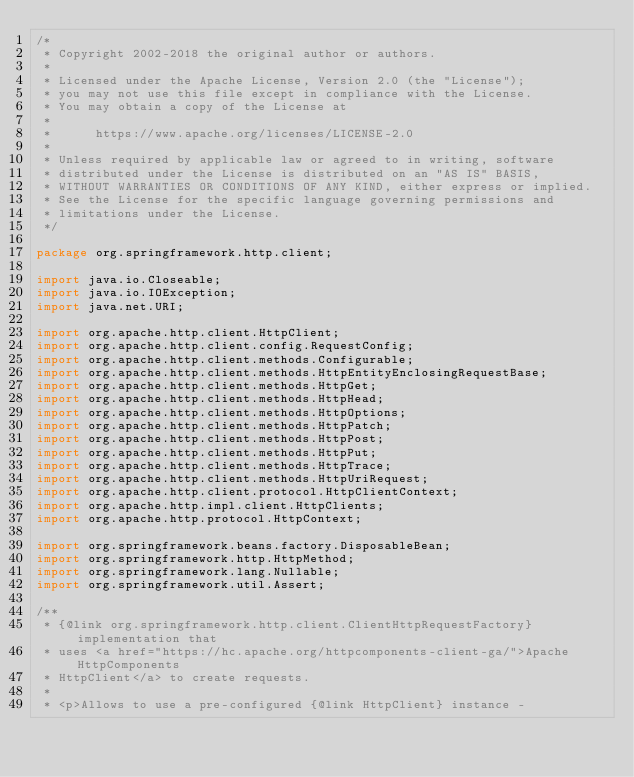Convert code to text. <code><loc_0><loc_0><loc_500><loc_500><_Java_>/*
 * Copyright 2002-2018 the original author or authors.
 *
 * Licensed under the Apache License, Version 2.0 (the "License");
 * you may not use this file except in compliance with the License.
 * You may obtain a copy of the License at
 *
 *      https://www.apache.org/licenses/LICENSE-2.0
 *
 * Unless required by applicable law or agreed to in writing, software
 * distributed under the License is distributed on an "AS IS" BASIS,
 * WITHOUT WARRANTIES OR CONDITIONS OF ANY KIND, either express or implied.
 * See the License for the specific language governing permissions and
 * limitations under the License.
 */

package org.springframework.http.client;

import java.io.Closeable;
import java.io.IOException;
import java.net.URI;

import org.apache.http.client.HttpClient;
import org.apache.http.client.config.RequestConfig;
import org.apache.http.client.methods.Configurable;
import org.apache.http.client.methods.HttpEntityEnclosingRequestBase;
import org.apache.http.client.methods.HttpGet;
import org.apache.http.client.methods.HttpHead;
import org.apache.http.client.methods.HttpOptions;
import org.apache.http.client.methods.HttpPatch;
import org.apache.http.client.methods.HttpPost;
import org.apache.http.client.methods.HttpPut;
import org.apache.http.client.methods.HttpTrace;
import org.apache.http.client.methods.HttpUriRequest;
import org.apache.http.client.protocol.HttpClientContext;
import org.apache.http.impl.client.HttpClients;
import org.apache.http.protocol.HttpContext;

import org.springframework.beans.factory.DisposableBean;
import org.springframework.http.HttpMethod;
import org.springframework.lang.Nullable;
import org.springframework.util.Assert;

/**
 * {@link org.springframework.http.client.ClientHttpRequestFactory} implementation that
 * uses <a href="https://hc.apache.org/httpcomponents-client-ga/">Apache HttpComponents
 * HttpClient</a> to create requests.
 *
 * <p>Allows to use a pre-configured {@link HttpClient} instance -</code> 